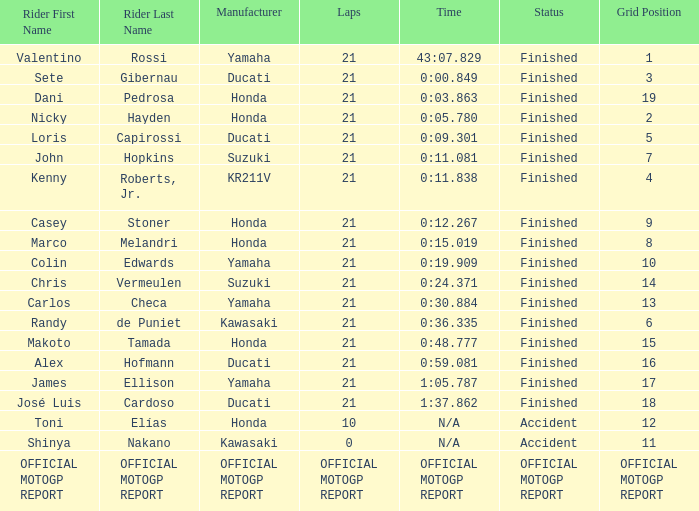WWhich rder had a vehicle manufactured by kr211v? Kenny Roberts, Jr. 